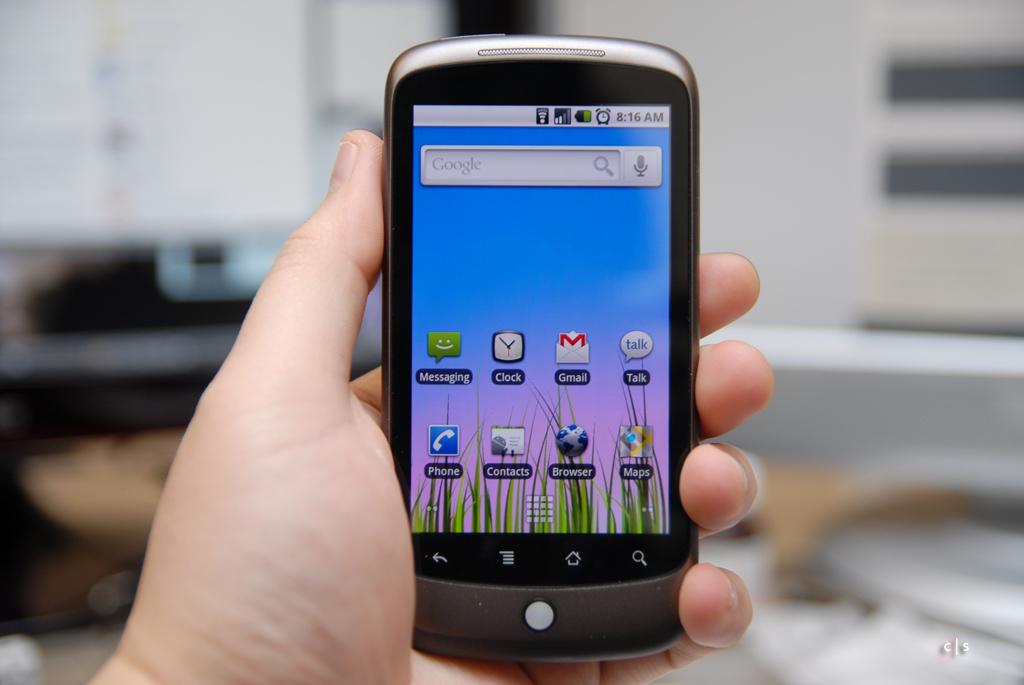What's the bottom left icon?
Ensure brevity in your answer.  Phone. What time is shown on the phone?
Your answer should be very brief. 8:16 am. 